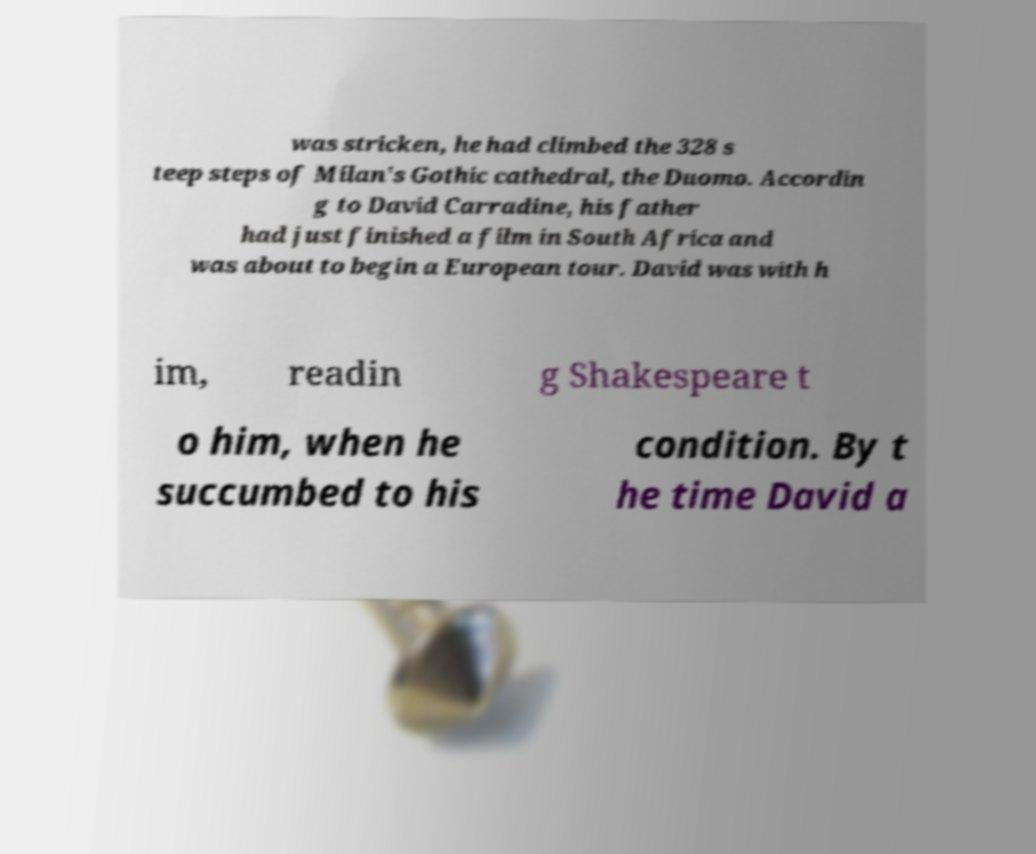For documentation purposes, I need the text within this image transcribed. Could you provide that? was stricken, he had climbed the 328 s teep steps of Milan's Gothic cathedral, the Duomo. Accordin g to David Carradine, his father had just finished a film in South Africa and was about to begin a European tour. David was with h im, readin g Shakespeare t o him, when he succumbed to his condition. By t he time David a 